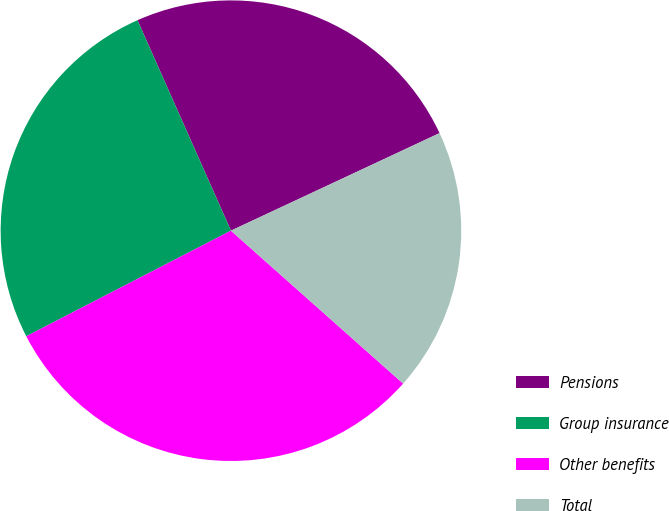<chart> <loc_0><loc_0><loc_500><loc_500><pie_chart><fcel>Pensions<fcel>Group insurance<fcel>Other benefits<fcel>Total<nl><fcel>24.69%<fcel>25.93%<fcel>30.86%<fcel>18.52%<nl></chart> 